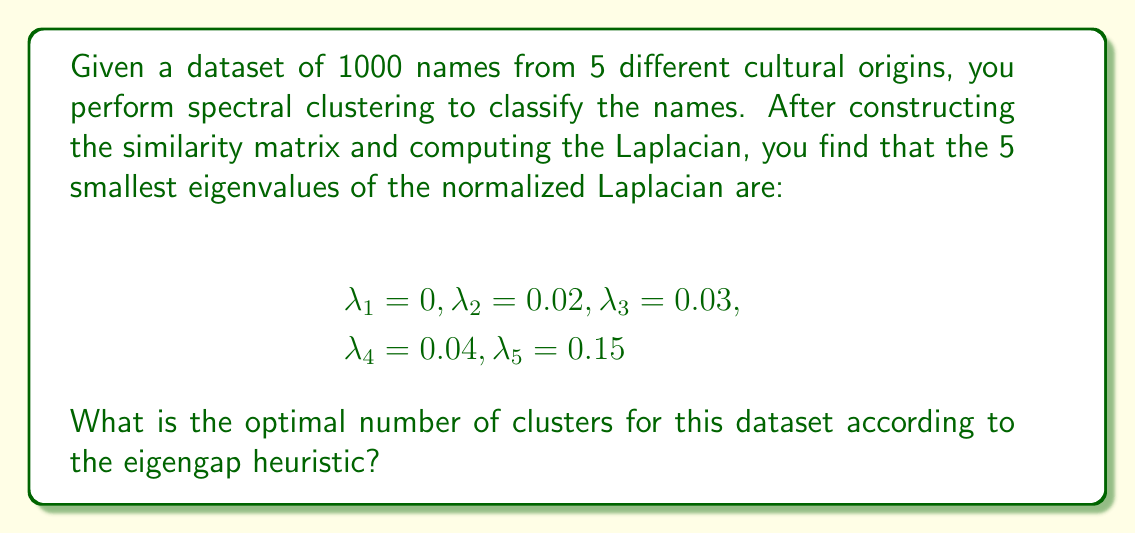Teach me how to tackle this problem. To determine the optimal number of clusters using the eigengap heuristic in spectral clustering, we follow these steps:

1. Examine the eigenvalues of the normalized Laplacian matrix in ascending order:
   $$\lambda_1 = 0, \lambda_2 = 0.02, \lambda_3 = 0.03, \lambda_4 = 0.04, \lambda_5 = 0.15$$

2. Calculate the differences (gaps) between consecutive eigenvalues:
   $$\text{gap}_1 = \lambda_2 - \lambda_1 = 0.02 - 0 = 0.02$$
   $$\text{gap}_2 = \lambda_3 - \lambda_2 = 0.03 - 0.02 = 0.01$$
   $$\text{gap}_3 = \lambda_4 - \lambda_3 = 0.04 - 0.03 = 0.01$$
   $$\text{gap}_4 = \lambda_5 - \lambda_4 = 0.15 - 0.04 = 0.11$$

3. Identify the largest gap:
   The largest gap is $\text{gap}_4 = 0.11$

4. The optimal number of clusters is the index of the largest gap:
   In this case, it's 4.

This result suggests that the names in the dataset can be effectively grouped into 4 distinct clusters based on their cultural origins, which aligns with the linguistic researcher's goal of studying the sociocultural impact of names in different communities.
Answer: 4 clusters 